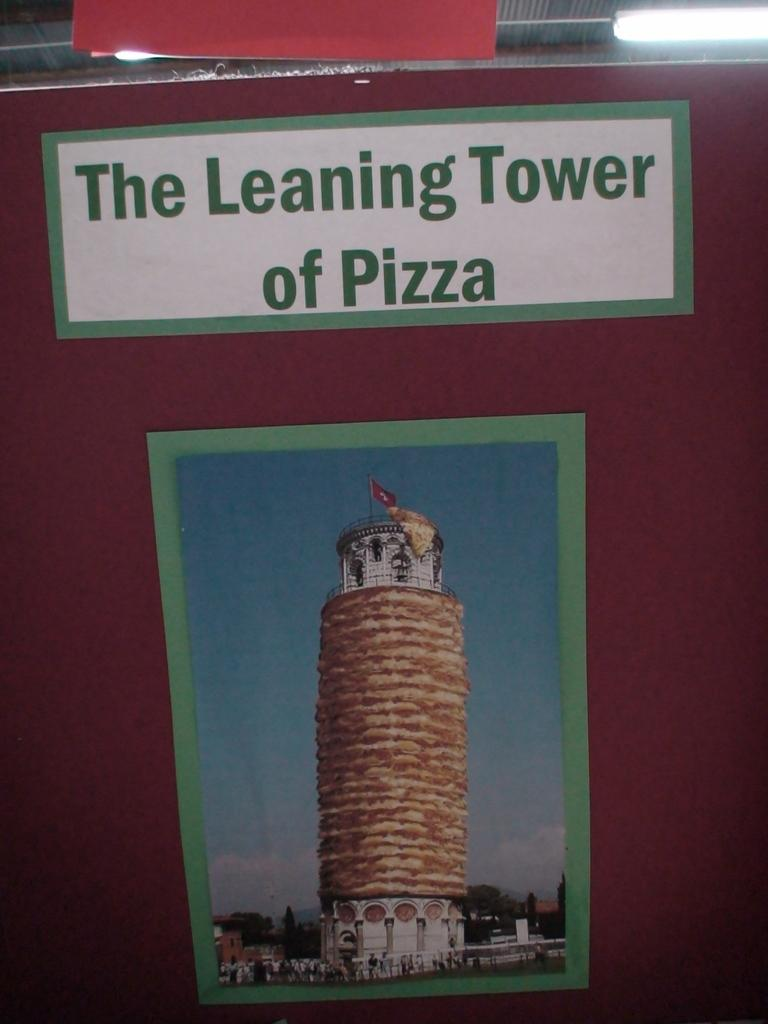<image>
Offer a succinct explanation of the picture presented. The famous Leaning Tower of Pizza is a parody of the building wrapped in pizzas. 